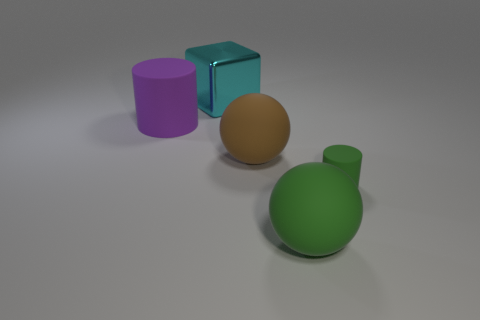What number of other cyan cubes have the same material as the cube?
Your answer should be compact. 0. There is another cylinder that is made of the same material as the small cylinder; what color is it?
Ensure brevity in your answer.  Purple. Are there fewer matte blocks than big purple things?
Provide a succinct answer. Yes. What material is the green object that is behind the matte object in front of the rubber cylinder on the right side of the cyan shiny thing made of?
Ensure brevity in your answer.  Rubber. What material is the purple cylinder?
Your answer should be compact. Rubber. Do the thing on the right side of the large green rubber thing and the matte ball in front of the small green rubber object have the same color?
Give a very brief answer. Yes. Is the number of big rubber balls greater than the number of large cyan things?
Your answer should be compact. Yes. How many matte spheres are the same color as the tiny object?
Your answer should be compact. 1. What color is the other object that is the same shape as the big brown thing?
Your answer should be compact. Green. What is the material of the object that is both behind the brown ball and in front of the big cyan metal object?
Provide a succinct answer. Rubber. 